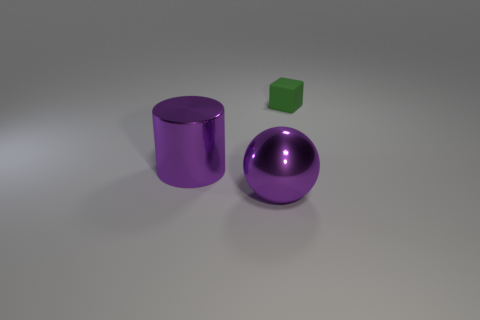The large purple metallic object that is behind the ball has what shape?
Provide a short and direct response. Cylinder. How many big brown metal cylinders are there?
Make the answer very short. 0. Is the purple sphere made of the same material as the purple cylinder?
Offer a terse response. Yes. Is the number of tiny matte objects to the right of the large purple metal cylinder greater than the number of purple things?
Provide a short and direct response. No. How many things are either big purple shiny cylinders or objects in front of the small object?
Make the answer very short. 2. Is the number of small green matte things right of the cube greater than the number of blocks that are behind the big purple cylinder?
Your response must be concise. No. What is the material of the object that is on the left side of the purple object in front of the large shiny thing left of the metal sphere?
Make the answer very short. Metal. There is a large purple object that is made of the same material as the ball; what is its shape?
Offer a very short reply. Cylinder. There is a big purple metallic object that is to the right of the purple cylinder; is there a purple cylinder that is in front of it?
Offer a terse response. No. What size is the cylinder?
Keep it short and to the point. Large. 